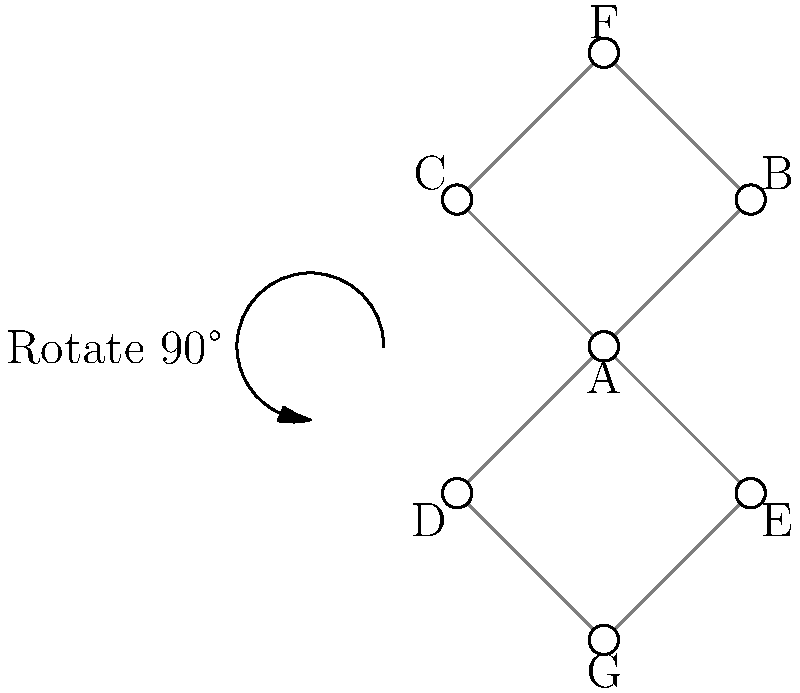Given the complex network graph shown above, which rotation angle would maximize the visibility of all nodes by minimizing overlap? Consider that the graph can be rotated around its center (node A) in 90-degree increments. To solve this problem, we need to analyze the graph structure and consider how different rotations would affect node visibility:

1. Current state (0° rotation):
   - Nodes B and C overlap with F
   - Nodes D and E overlap with G

2. 90° clockwise rotation:
   - Node F would overlap with E
   - Node G would overlap with C
   - Nodes B and D would be clearly visible

3. 180° rotation:
   - Nodes B and C would overlap with G
   - Nodes D and E would overlap with F

4. 270° clockwise rotation (or 90° counterclockwise):
   - Node F would overlap with D
   - Node G would overlap with B
   - Nodes C and E would be clearly visible

Analyzing these rotations, we can see that the 90° clockwise rotation provides the best visibility:
- It reduces the number of overlapping nodes from 4 to 2
- It clearly separates the vertical axis (B-A-D) from the horizontal axis (C-A-E)
- Nodes F and G, while still overlapping with other nodes, are positioned in a way that makes their connections more visible

Therefore, a 90° clockwise rotation would maximize node visibility in this complex network graph.
Answer: 90° clockwise 